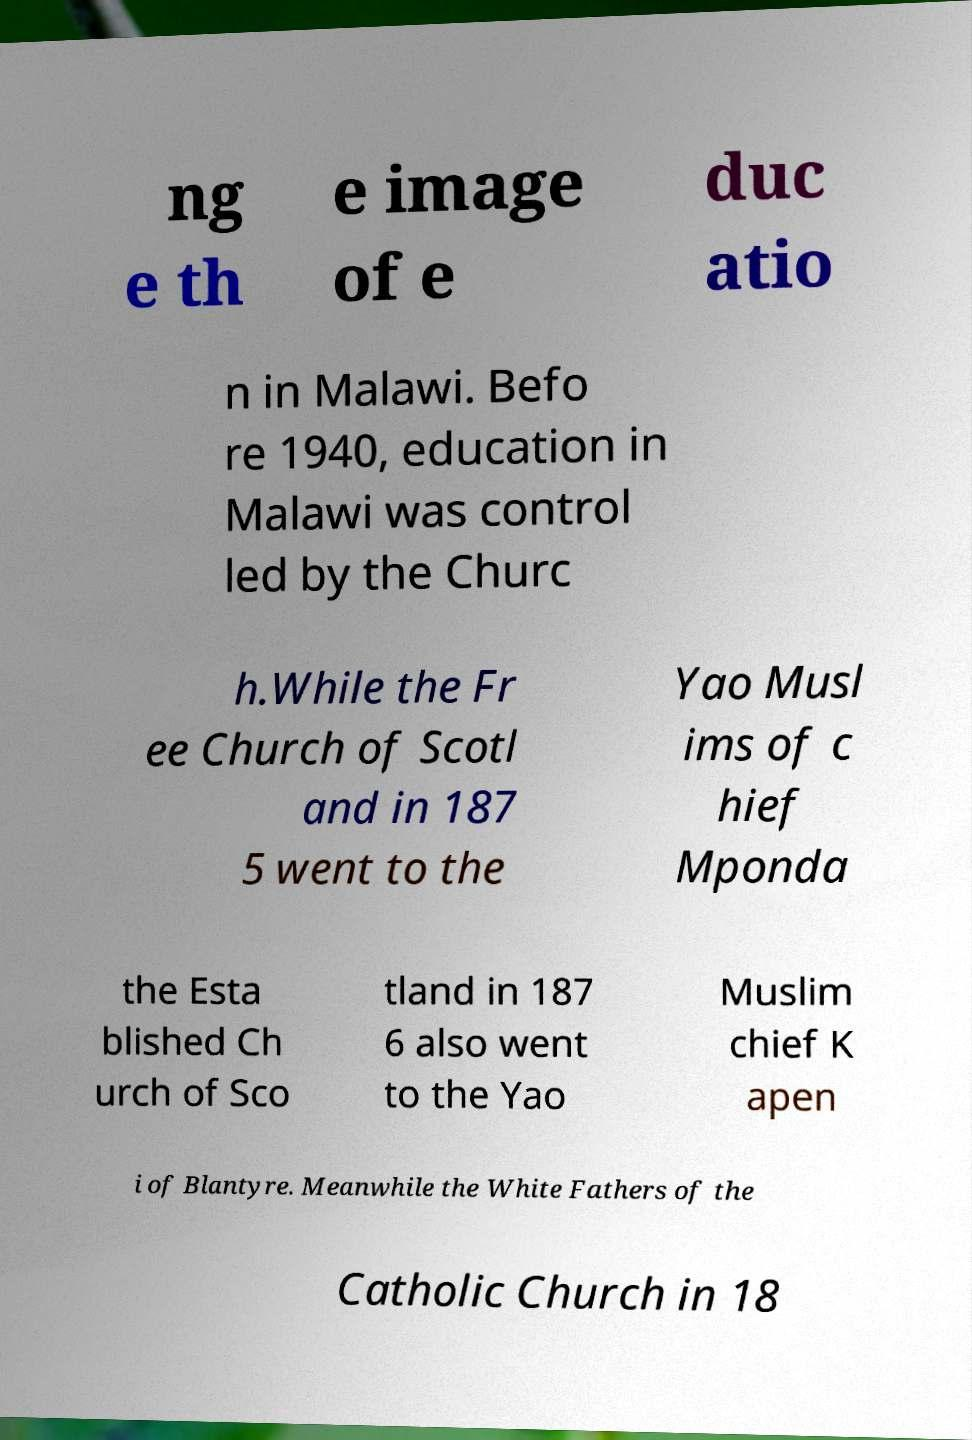There's text embedded in this image that I need extracted. Can you transcribe it verbatim? ng e th e image of e duc atio n in Malawi. Befo re 1940, education in Malawi was control led by the Churc h.While the Fr ee Church of Scotl and in 187 5 went to the Yao Musl ims of c hief Mponda the Esta blished Ch urch of Sco tland in 187 6 also went to the Yao Muslim chief K apen i of Blantyre. Meanwhile the White Fathers of the Catholic Church in 18 